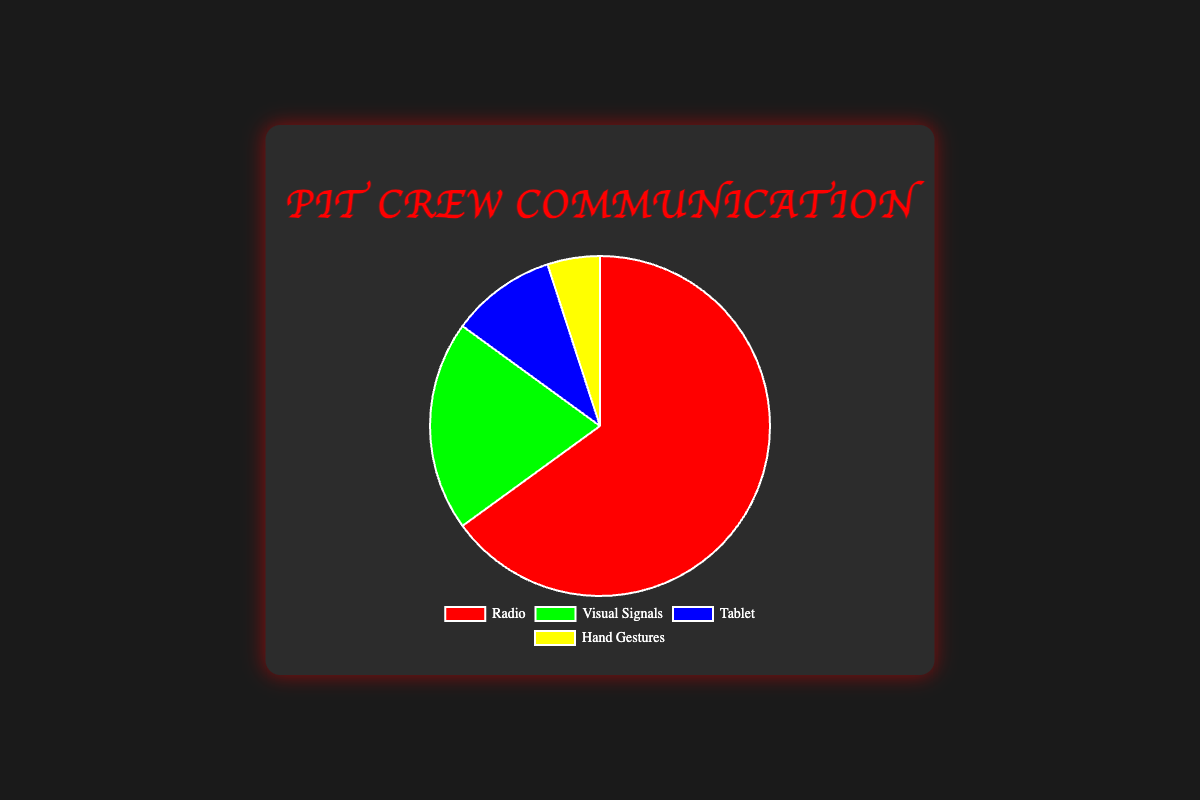What percentage of communication is done through the Tablet during a race? The chart shows four communication channels and their respective percentages. The Tablet channel specifically shows a percentage of 10%.
Answer: 10% Which communication channel is used the most? The chart presents four channels: Radio, Visual Signals, Tablet, and Hand Gestures. Radio has the highest percentage of 65%.
Answer: Radio How much more frequently is the Radio used compared to Visual Signals? The Radio is used 65% of the time, while Visual Signals are used 20% of the time. The difference between these percentages is 65% - 20% = 45%.
Answer: 45% What are the percentages for Visual Signals and Hand Gestures combined? Visual Signals are at 20% and Hand Gestures are at 5%. Adding these together gives 20% + 5% = 25%.
Answer: 25% If you combined all communication methods other than Radio, what percentage would that be? The percentages for Visual Signals, Tablet, and Hand Gestures are 20%, 10%, and 5% respectively. The sum is 20% + 10% + 5% = 35%.
Answer: 35% Which channel uses the yellow color in the pie chart? The Hand Gestures segment is displayed in yellow on the pie chart.
Answer: Hand Gestures Is the percentage of communication using Hand Gestures greater than or less than the percentage using the Tablet? Hand Gestures are used 5% of the time, which is less than the Tablet percentage of 10%.
Answer: Less than By how much does communication via Visual Signals exceed communication via Hand Gestures? Visual Signals are at 20%, while Hand Gestures are at 5%. The difference is 20% - 5% = 15%.
Answer: 15% Which communication channel, excluding Radio, has the highest percentage? Excluding Radio, which is at 65%, Visual Signals have the highest percentage at 20%.
Answer: Visual Signals How much more frequently is communication via Visual Signals used compared to the Tablet? Visual Signals are used 20% of the time and the Tablet is used 10% of the time. The difference is 20% - 10% = 10%.
Answer: 10% 